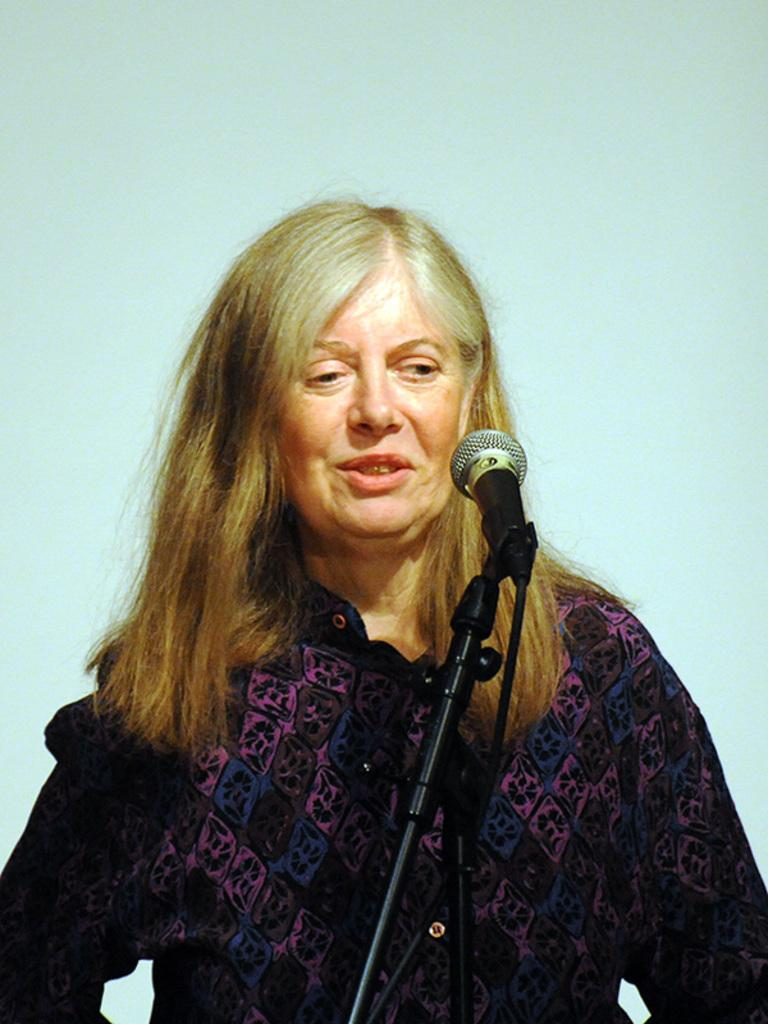What is the main subject of the image? There is a woman standing in the image. What object is located at the front of the image? There is a microphone at the front of the image. What color is the background of the image? The background of the image is white. Can you see any ants crawling on the woman in the image? There are no ants present in the image. Is there a cave visible in the background of the image? There is no cave present in the image; the background is white. 